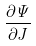<formula> <loc_0><loc_0><loc_500><loc_500>\frac { \partial \Psi } { \partial J }</formula> 